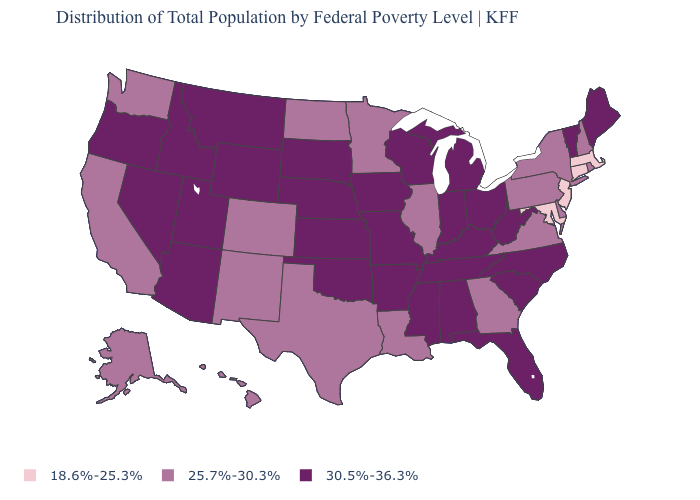What is the highest value in the USA?
Be succinct. 30.5%-36.3%. What is the value of Texas?
Short answer required. 25.7%-30.3%. How many symbols are there in the legend?
Be succinct. 3. What is the value of North Carolina?
Answer briefly. 30.5%-36.3%. Does the map have missing data?
Keep it brief. No. Does Hawaii have the highest value in the West?
Answer briefly. No. Name the states that have a value in the range 18.6%-25.3%?
Concise answer only. Connecticut, Maryland, Massachusetts, New Jersey. What is the lowest value in the USA?
Quick response, please. 18.6%-25.3%. Which states have the lowest value in the USA?
Quick response, please. Connecticut, Maryland, Massachusetts, New Jersey. How many symbols are there in the legend?
Keep it brief. 3. Does Oklahoma have the same value as Illinois?
Give a very brief answer. No. Name the states that have a value in the range 30.5%-36.3%?
Give a very brief answer. Alabama, Arizona, Arkansas, Florida, Idaho, Indiana, Iowa, Kansas, Kentucky, Maine, Michigan, Mississippi, Missouri, Montana, Nebraska, Nevada, North Carolina, Ohio, Oklahoma, Oregon, South Carolina, South Dakota, Tennessee, Utah, Vermont, West Virginia, Wisconsin, Wyoming. What is the lowest value in the Northeast?
Write a very short answer. 18.6%-25.3%. What is the value of New York?
Quick response, please. 25.7%-30.3%. 